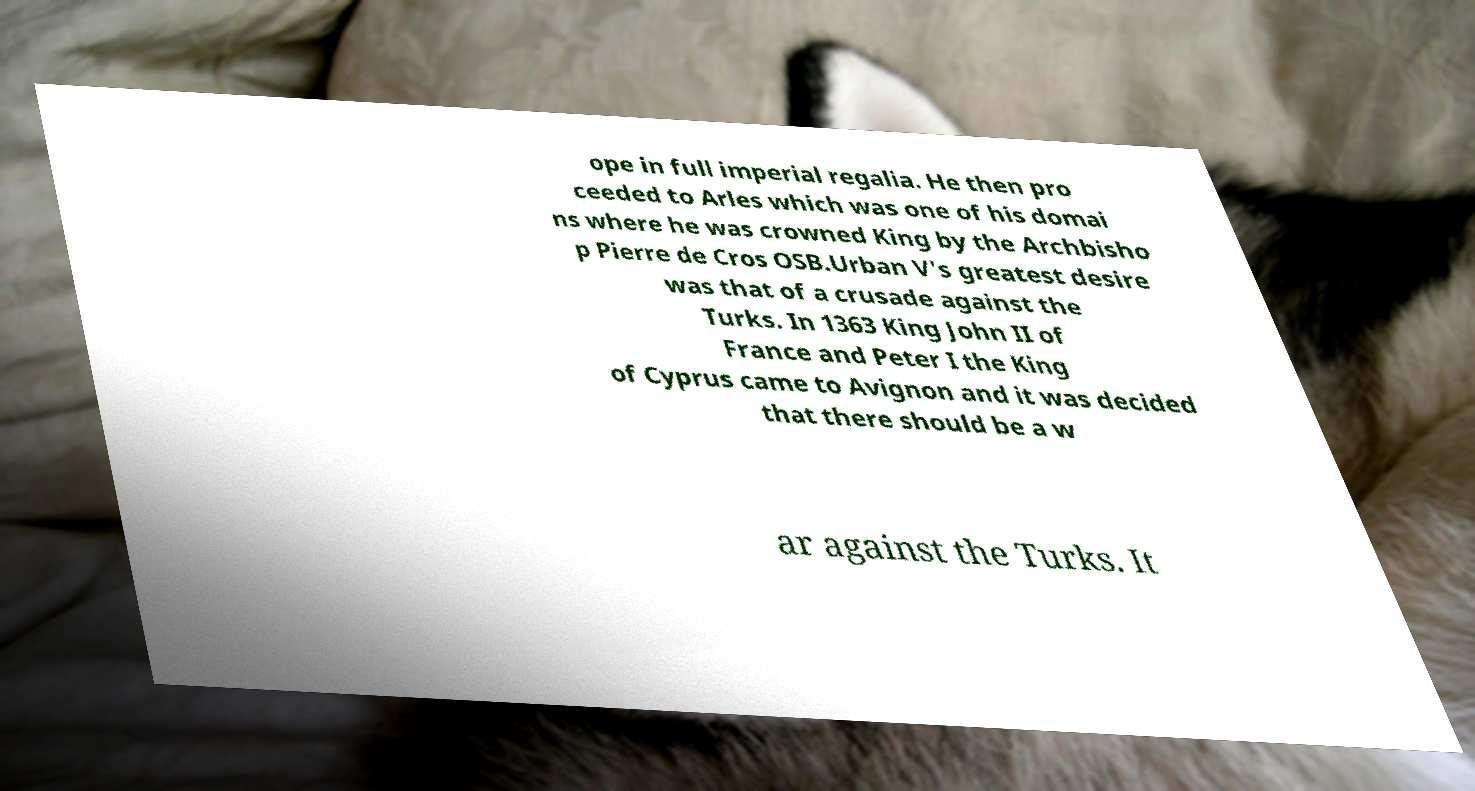What messages or text are displayed in this image? I need them in a readable, typed format. ope in full imperial regalia. He then pro ceeded to Arles which was one of his domai ns where he was crowned King by the Archbisho p Pierre de Cros OSB.Urban V's greatest desire was that of a crusade against the Turks. In 1363 King John II of France and Peter I the King of Cyprus came to Avignon and it was decided that there should be a w ar against the Turks. It 